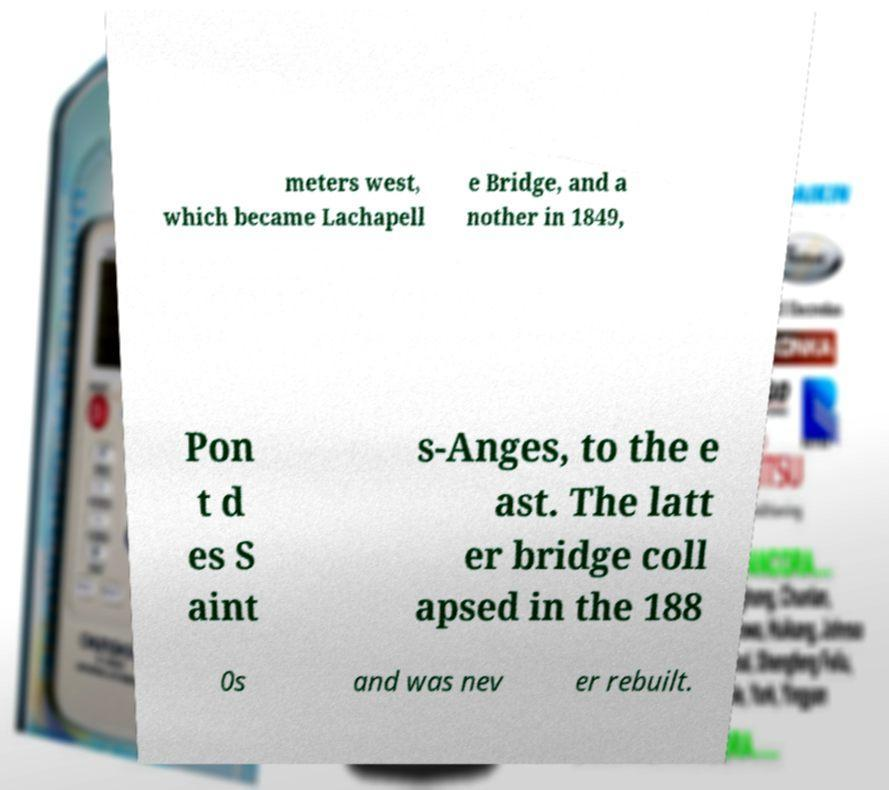Could you extract and type out the text from this image? meters west, which became Lachapell e Bridge, and a nother in 1849, Pon t d es S aint s-Anges, to the e ast. The latt er bridge coll apsed in the 188 0s and was nev er rebuilt. 